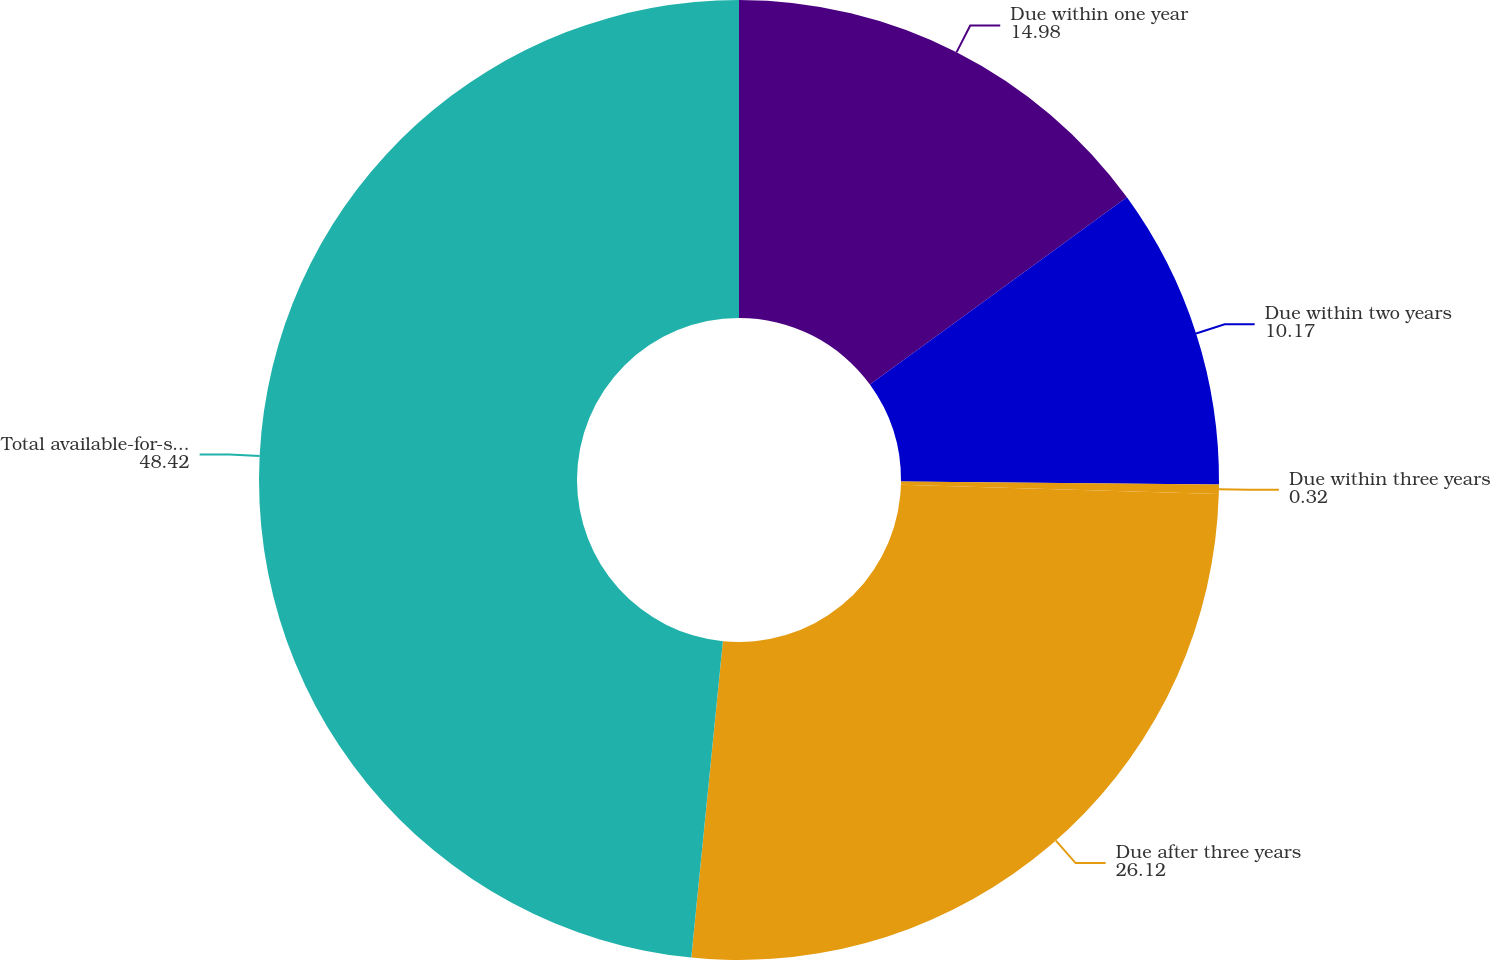<chart> <loc_0><loc_0><loc_500><loc_500><pie_chart><fcel>Due within one year<fcel>Due within two years<fcel>Due within three years<fcel>Due after three years<fcel>Total available-for-sale debt<nl><fcel>14.98%<fcel>10.17%<fcel>0.32%<fcel>26.12%<fcel>48.42%<nl></chart> 